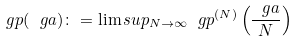Convert formula to latex. <formula><loc_0><loc_0><loc_500><loc_500>\ g p ( \ g a ) \colon = \lim s u p _ { N \to \infty } \ g p ^ { ( N ) } \left ( \frac { \ g a } { N } \right )</formula> 